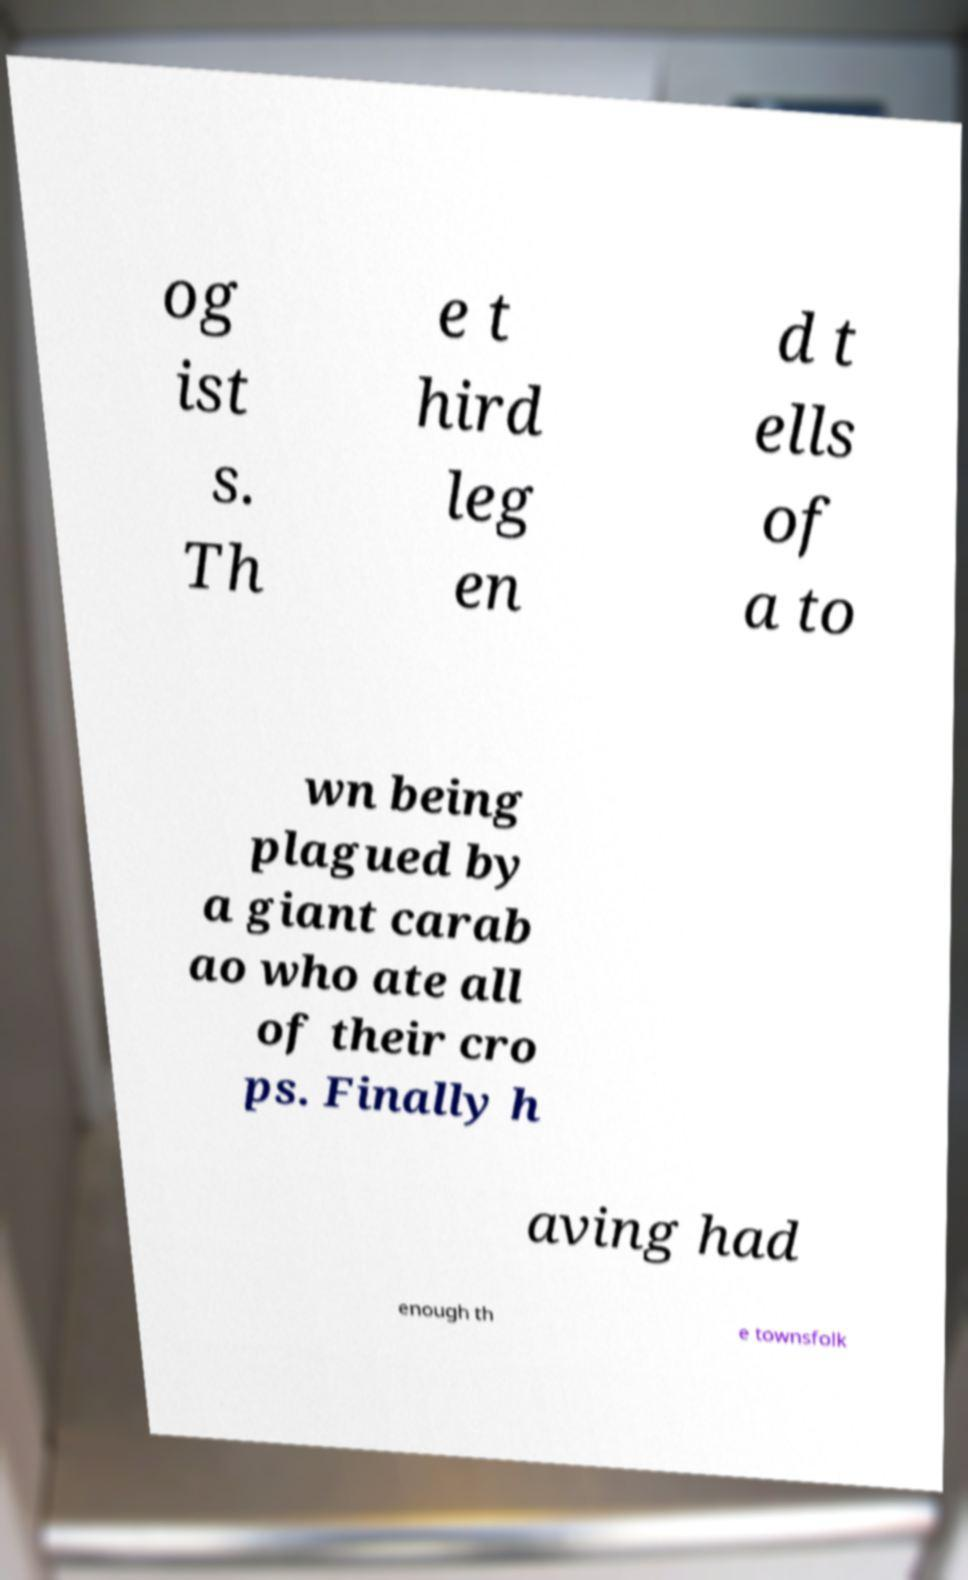What messages or text are displayed in this image? I need them in a readable, typed format. og ist s. Th e t hird leg en d t ells of a to wn being plagued by a giant carab ao who ate all of their cro ps. Finally h aving had enough th e townsfolk 